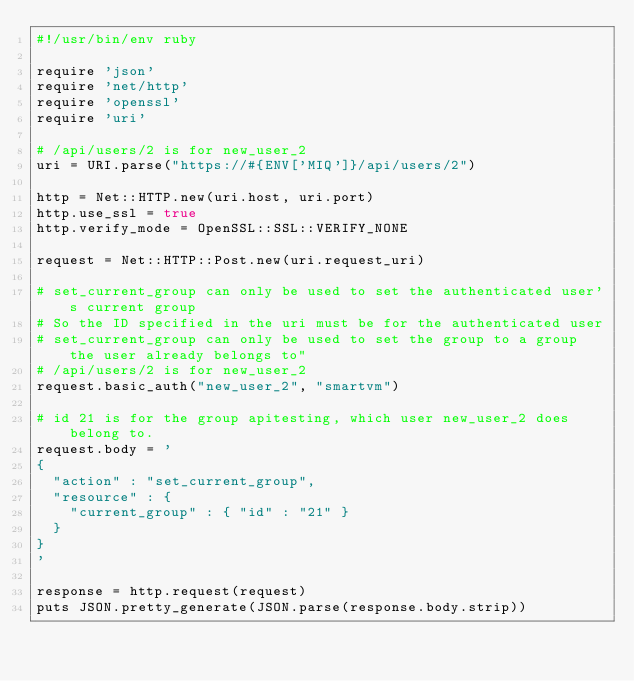<code> <loc_0><loc_0><loc_500><loc_500><_Ruby_>#!/usr/bin/env ruby

require 'json'
require 'net/http'
require 'openssl'
require 'uri'

# /api/users/2 is for new_user_2
uri = URI.parse("https://#{ENV['MIQ']}/api/users/2")

http = Net::HTTP.new(uri.host, uri.port)
http.use_ssl = true
http.verify_mode = OpenSSL::SSL::VERIFY_NONE

request = Net::HTTP::Post.new(uri.request_uri)

# set_current_group can only be used to set the authenticated user's current group
# So the ID specified in the uri must be for the authenticated user
# set_current_group can only be used to set the group to a group the user already belongs to"
# /api/users/2 is for new_user_2
request.basic_auth("new_user_2", "smartvm")

# id 21 is for the group apitesting, which user new_user_2 does belong to.
request.body = '
{
  "action" : "set_current_group",
  "resource" : {
    "current_group" : { "id" : "21" }
  }
}
'

response = http.request(request)
puts JSON.pretty_generate(JSON.parse(response.body.strip))

</code> 